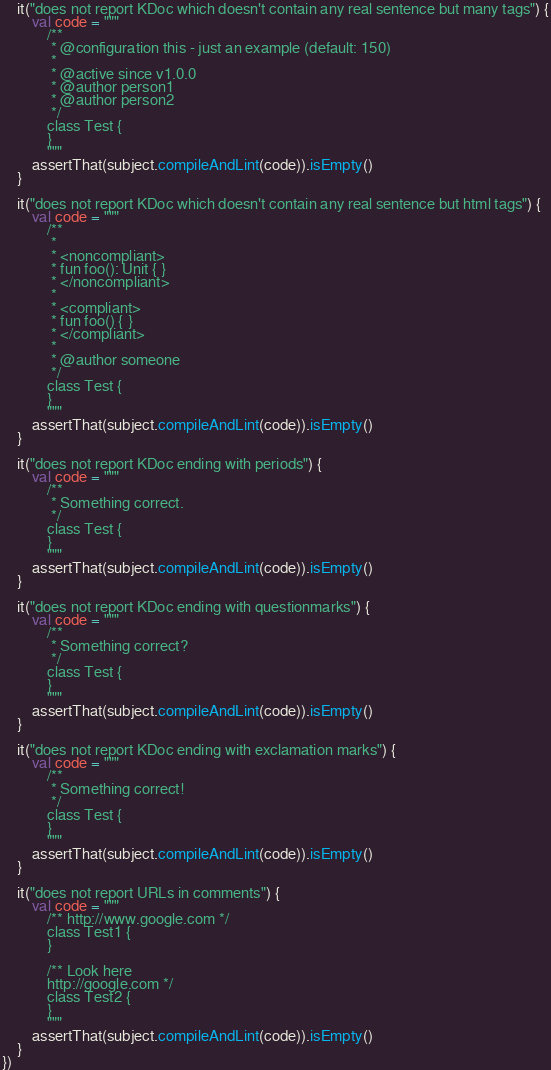Convert code to text. <code><loc_0><loc_0><loc_500><loc_500><_Kotlin_>	it("does not report KDoc which doesn't contain any real sentence but many tags") {
		val code = """
			/**
			 * @configuration this - just an example (default: 150)
			 *
			 * @active since v1.0.0
			 * @author person1
			 * @author person2
			 */
			class Test {
			}
			"""
		assertThat(subject.compileAndLint(code)).isEmpty()
	}

	it("does not report KDoc which doesn't contain any real sentence but html tags") {
		val code = """
			/**
			 *
			 * <noncompliant>
			 * fun foo(): Unit { }
			 * </noncompliant>
			 *
			 * <compliant>
			 * fun foo() { }
			 * </compliant>
			 *
			 * @author someone
			 */
			class Test {
			}
			"""
		assertThat(subject.compileAndLint(code)).isEmpty()
	}

	it("does not report KDoc ending with periods") {
		val code = """
			/**
			 * Something correct.
			 */
			class Test {
			}
			"""
		assertThat(subject.compileAndLint(code)).isEmpty()
	}

	it("does not report KDoc ending with questionmarks") {
		val code = """
			/**
			 * Something correct?
			 */
			class Test {
			}
			"""
		assertThat(subject.compileAndLint(code)).isEmpty()
	}

	it("does not report KDoc ending with exclamation marks") {
		val code = """
			/**
			 * Something correct!
			 */
			class Test {
			}
			"""
		assertThat(subject.compileAndLint(code)).isEmpty()
	}

	it("does not report URLs in comments") {
		val code = """
			/** http://www.google.com */
			class Test1 {
			}

			/** Look here
			http://google.com */
			class Test2 {
			}
			"""
		assertThat(subject.compileAndLint(code)).isEmpty()
	}
})
</code> 